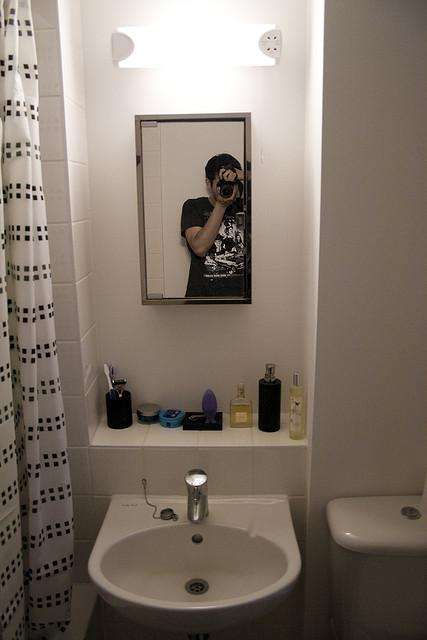A digital single lens reflex is normally known as? dslr 